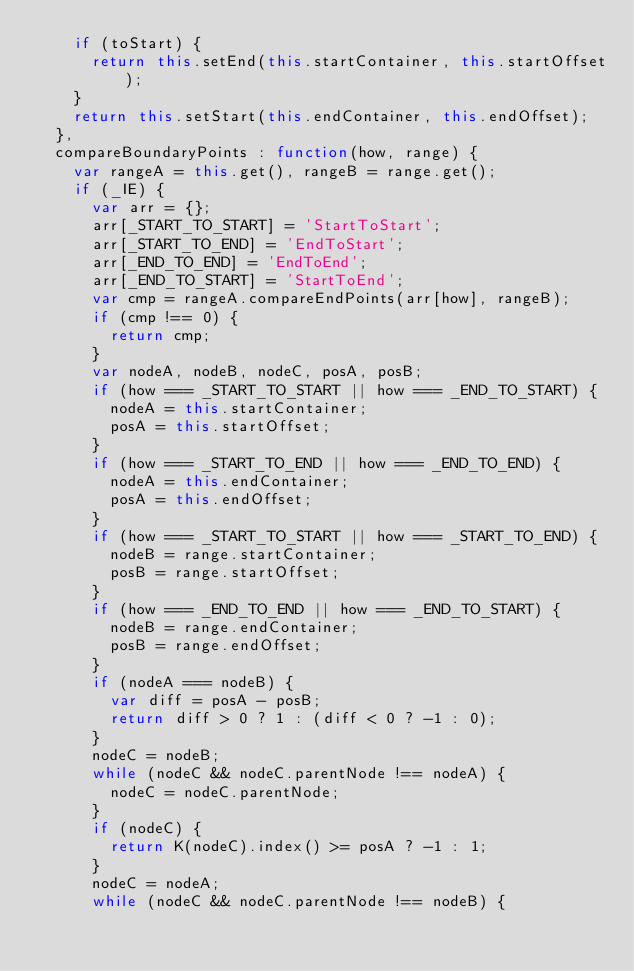<code> <loc_0><loc_0><loc_500><loc_500><_JavaScript_>		if (toStart) {
			return this.setEnd(this.startContainer, this.startOffset);
		}
		return this.setStart(this.endContainer, this.endOffset);
	},
	compareBoundaryPoints : function(how, range) {
		var rangeA = this.get(), rangeB = range.get();
		if (_IE) {
			var arr = {};
			arr[_START_TO_START] = 'StartToStart';
			arr[_START_TO_END] = 'EndToStart';
			arr[_END_TO_END] = 'EndToEnd';
			arr[_END_TO_START] = 'StartToEnd';
			var cmp = rangeA.compareEndPoints(arr[how], rangeB);
			if (cmp !== 0) {
				return cmp;
			}
			var nodeA, nodeB, nodeC, posA, posB;
			if (how === _START_TO_START || how === _END_TO_START) {
				nodeA = this.startContainer;
				posA = this.startOffset;
			}
			if (how === _START_TO_END || how === _END_TO_END) {
				nodeA = this.endContainer;
				posA = this.endOffset;
			}
			if (how === _START_TO_START || how === _START_TO_END) {
				nodeB = range.startContainer;
				posB = range.startOffset;
			}
			if (how === _END_TO_END || how === _END_TO_START) {
				nodeB = range.endContainer;
				posB = range.endOffset;
			}
			if (nodeA === nodeB) {
				var diff = posA - posB;
				return diff > 0 ? 1 : (diff < 0 ? -1 : 0);
			}
			nodeC = nodeB;
			while (nodeC && nodeC.parentNode !== nodeA) {
				nodeC = nodeC.parentNode;
			}
			if (nodeC) {
				return K(nodeC).index() >= posA ? -1 : 1;
			}
			nodeC = nodeA;
			while (nodeC && nodeC.parentNode !== nodeB) {</code> 